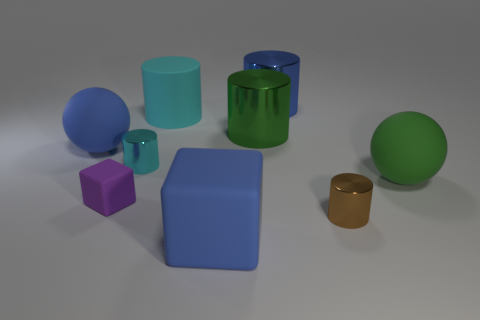Subtract all big cyan rubber cylinders. How many cylinders are left? 4 Subtract all gray cylinders. Subtract all gray blocks. How many cylinders are left? 5 Subtract all cylinders. How many objects are left? 4 Add 1 things. How many things are left? 10 Add 3 yellow things. How many yellow things exist? 3 Subtract 0 purple cylinders. How many objects are left? 9 Subtract all green rubber balls. Subtract all purple blocks. How many objects are left? 7 